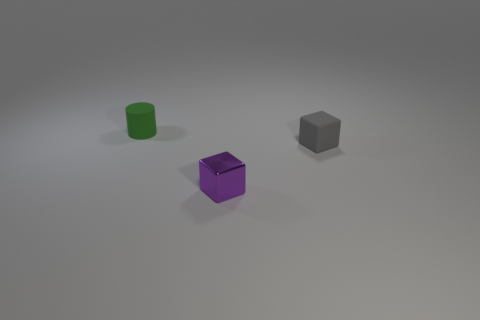Is the color of the shiny thing the same as the rubber block?
Offer a terse response. No. Is there a small purple object that has the same material as the gray cube?
Your response must be concise. No. The small object on the right side of the block that is on the left side of the matte thing on the right side of the tiny green matte thing is what shape?
Make the answer very short. Cube. What is the small cylinder made of?
Ensure brevity in your answer.  Rubber. There is a object that is made of the same material as the small gray block; what is its color?
Provide a short and direct response. Green. Is there a purple cube behind the small rubber object that is in front of the green rubber object?
Give a very brief answer. No. What number of other objects are the same shape as the tiny purple object?
Provide a short and direct response. 1. There is a tiny matte object that is behind the gray object; does it have the same shape as the thing right of the purple cube?
Provide a succinct answer. No. There is a small rubber thing to the left of the matte object in front of the green thing; how many things are in front of it?
Offer a very short reply. 2. What color is the small cylinder?
Offer a very short reply. Green. 